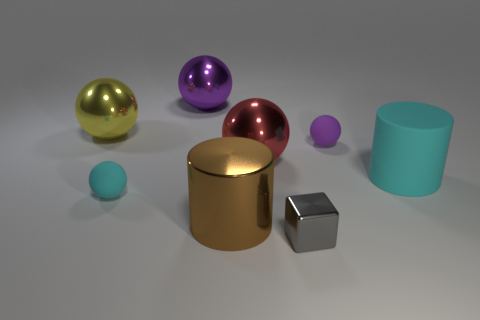The small matte thing that is the same color as the big matte thing is what shape?
Your response must be concise. Sphere. What is the color of the other large object that is the same shape as the brown metallic object?
Keep it short and to the point. Cyan. The purple metallic thing has what size?
Provide a short and direct response. Large. What number of other matte spheres are the same size as the red ball?
Offer a terse response. 0. Do the small cube and the rubber cylinder have the same color?
Give a very brief answer. No. Does the red object behind the brown shiny thing have the same material as the cylinder that is left of the tiny gray thing?
Provide a short and direct response. Yes. Are there more shiny things than small gray blocks?
Keep it short and to the point. Yes. Is there anything else that is the same color as the tiny metallic cube?
Provide a succinct answer. No. Is the yellow sphere made of the same material as the large cyan object?
Your response must be concise. No. Are there fewer large red rubber objects than yellow spheres?
Offer a very short reply. Yes. 